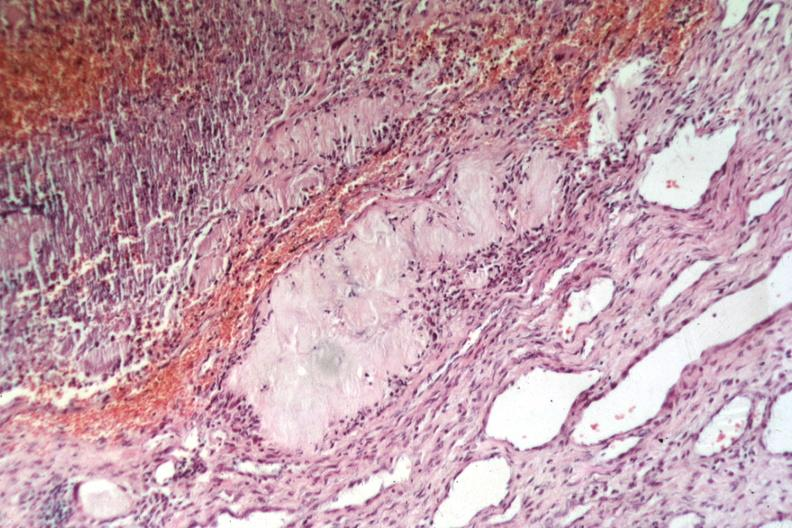s tophus present?
Answer the question using a single word or phrase. Yes 